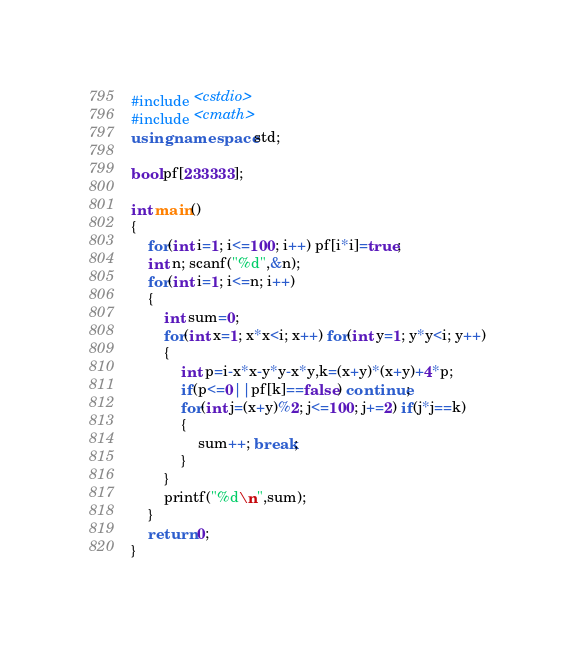Convert code to text. <code><loc_0><loc_0><loc_500><loc_500><_C++_>#include <cstdio>
#include <cmath>
using namespace std;

bool pf[233333];

int main()
{
	for(int i=1; i<=100; i++) pf[i*i]=true;
	int n; scanf("%d",&n);
	for(int i=1; i<=n; i++)
	{
		int sum=0;
		for(int x=1; x*x<i; x++) for(int y=1; y*y<i; y++)
		{
			int p=i-x*x-y*y-x*y,k=(x+y)*(x+y)+4*p;
			if(p<=0||pf[k]==false) continue;
			for(int j=(x+y)%2; j<=100; j+=2) if(j*j==k)
			{
				sum++; break;
			}
		}
		printf("%d\n",sum);
	}
	return 0;
}</code> 